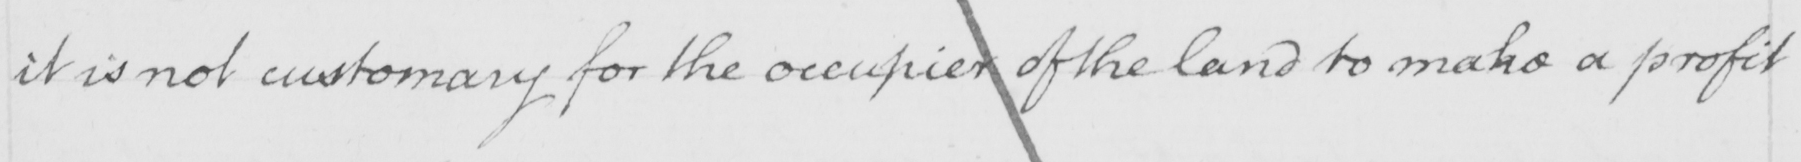What text is written in this handwritten line? it is not customary for the occupier of the land to make a profit 